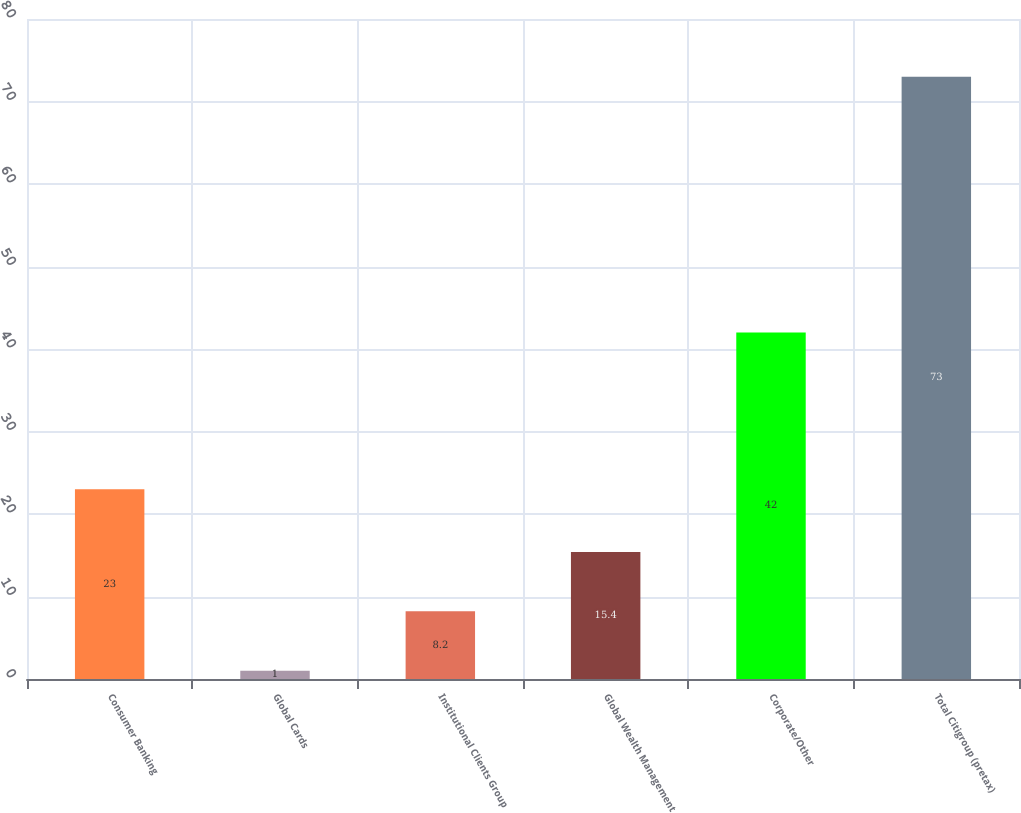<chart> <loc_0><loc_0><loc_500><loc_500><bar_chart><fcel>Consumer Banking<fcel>Global Cards<fcel>Institutional Clients Group<fcel>Global Wealth Management<fcel>Corporate/Other<fcel>Total Citigroup (pretax)<nl><fcel>23<fcel>1<fcel>8.2<fcel>15.4<fcel>42<fcel>73<nl></chart> 